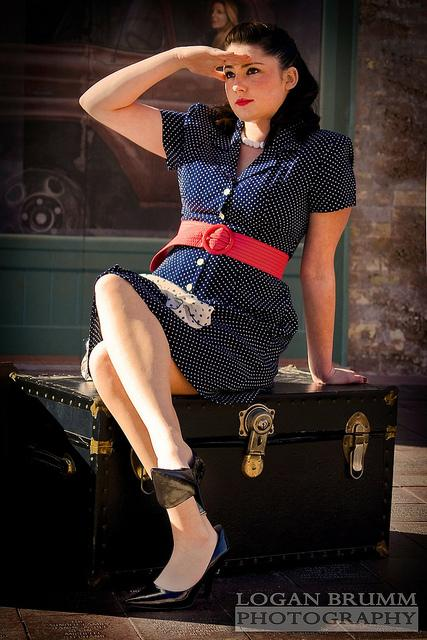What is usually held in the item being sat on here?

Choices:
A) dogs
B) coffee
C) bibles
D) clothing clothing 